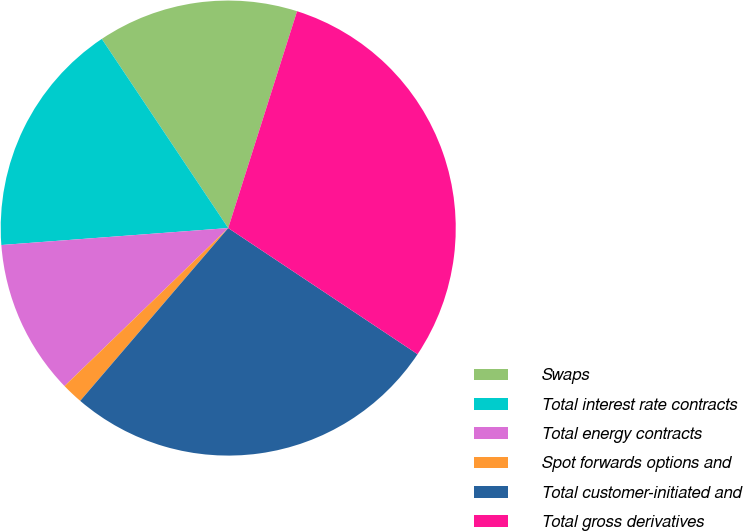<chart> <loc_0><loc_0><loc_500><loc_500><pie_chart><fcel>Swaps<fcel>Total interest rate contracts<fcel>Total energy contracts<fcel>Spot forwards options and<fcel>Total customer-initiated and<fcel>Total gross derivatives<nl><fcel>14.27%<fcel>16.81%<fcel>11.03%<fcel>1.51%<fcel>26.92%<fcel>29.46%<nl></chart> 